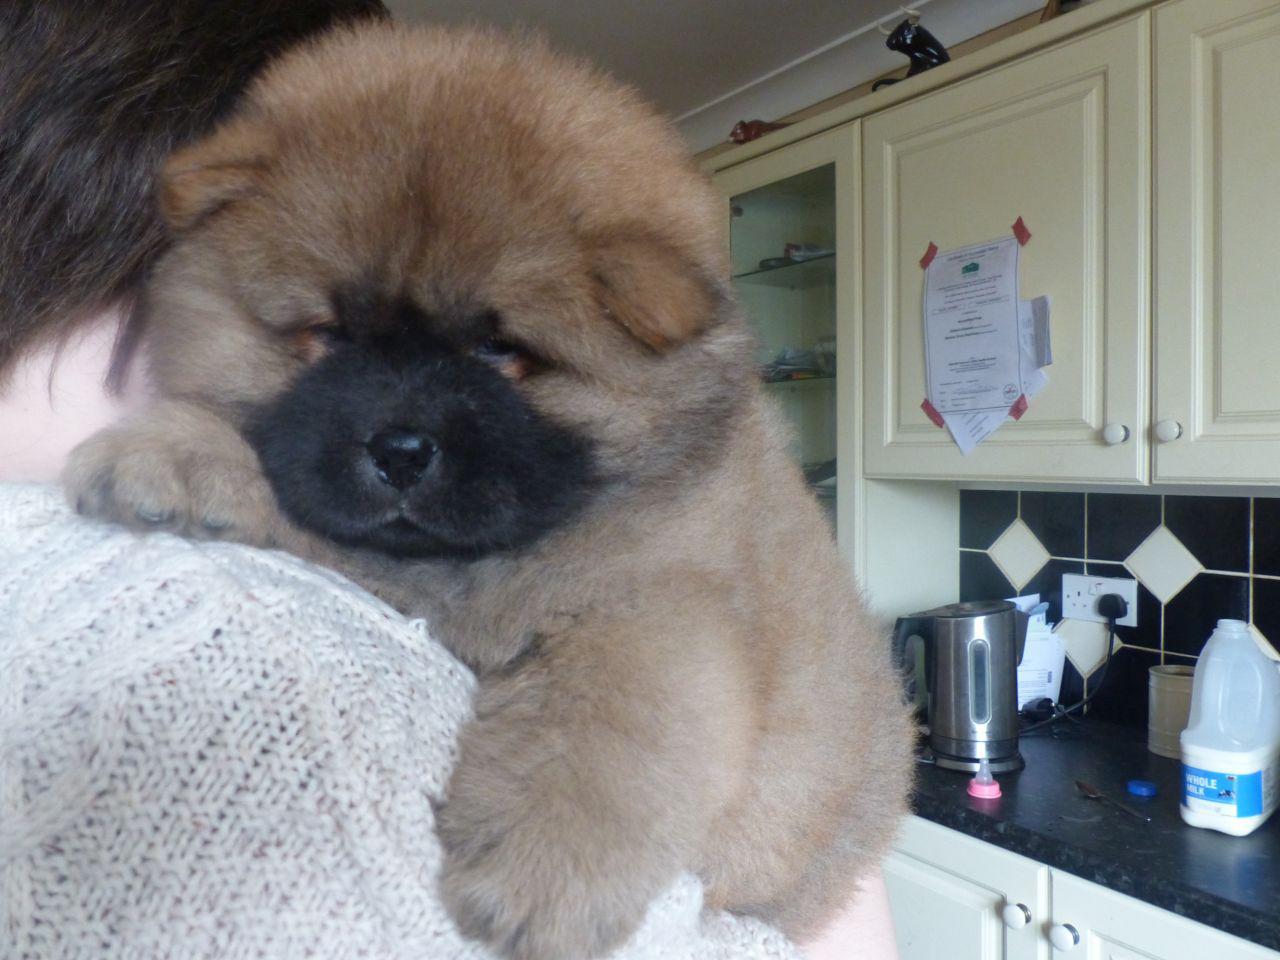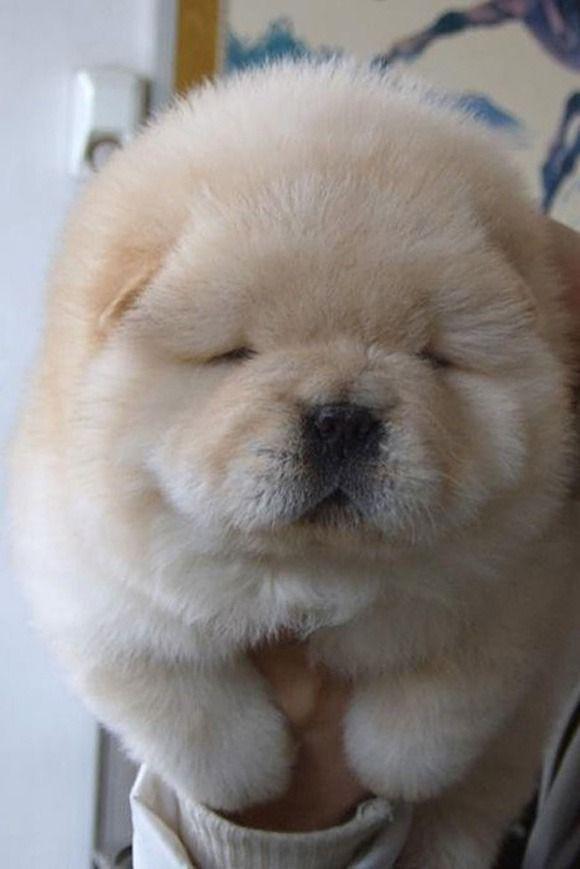The first image is the image on the left, the second image is the image on the right. Assess this claim about the two images: "All images show only very young chow pups, and each image shows the same number.". Correct or not? Answer yes or no. Yes. The first image is the image on the left, the second image is the image on the right. Analyze the images presented: Is the assertion "There is a person holding exactly one dog in the image on the left" valid? Answer yes or no. Yes. 